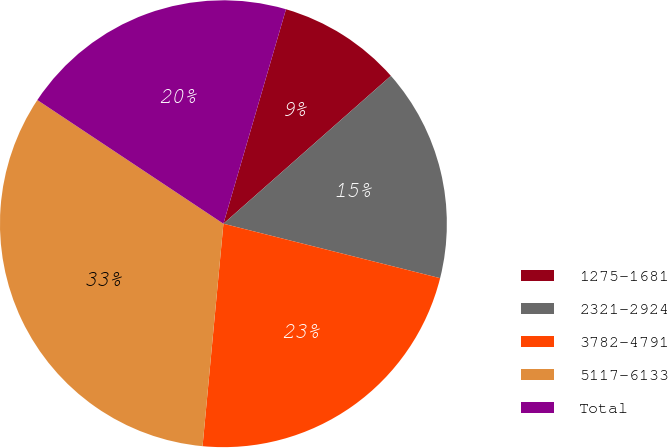Convert chart to OTSL. <chart><loc_0><loc_0><loc_500><loc_500><pie_chart><fcel>1275-1681<fcel>2321-2924<fcel>3782-4791<fcel>5117-6133<fcel>Total<nl><fcel>8.97%<fcel>15.43%<fcel>22.57%<fcel>32.85%<fcel>20.18%<nl></chart> 